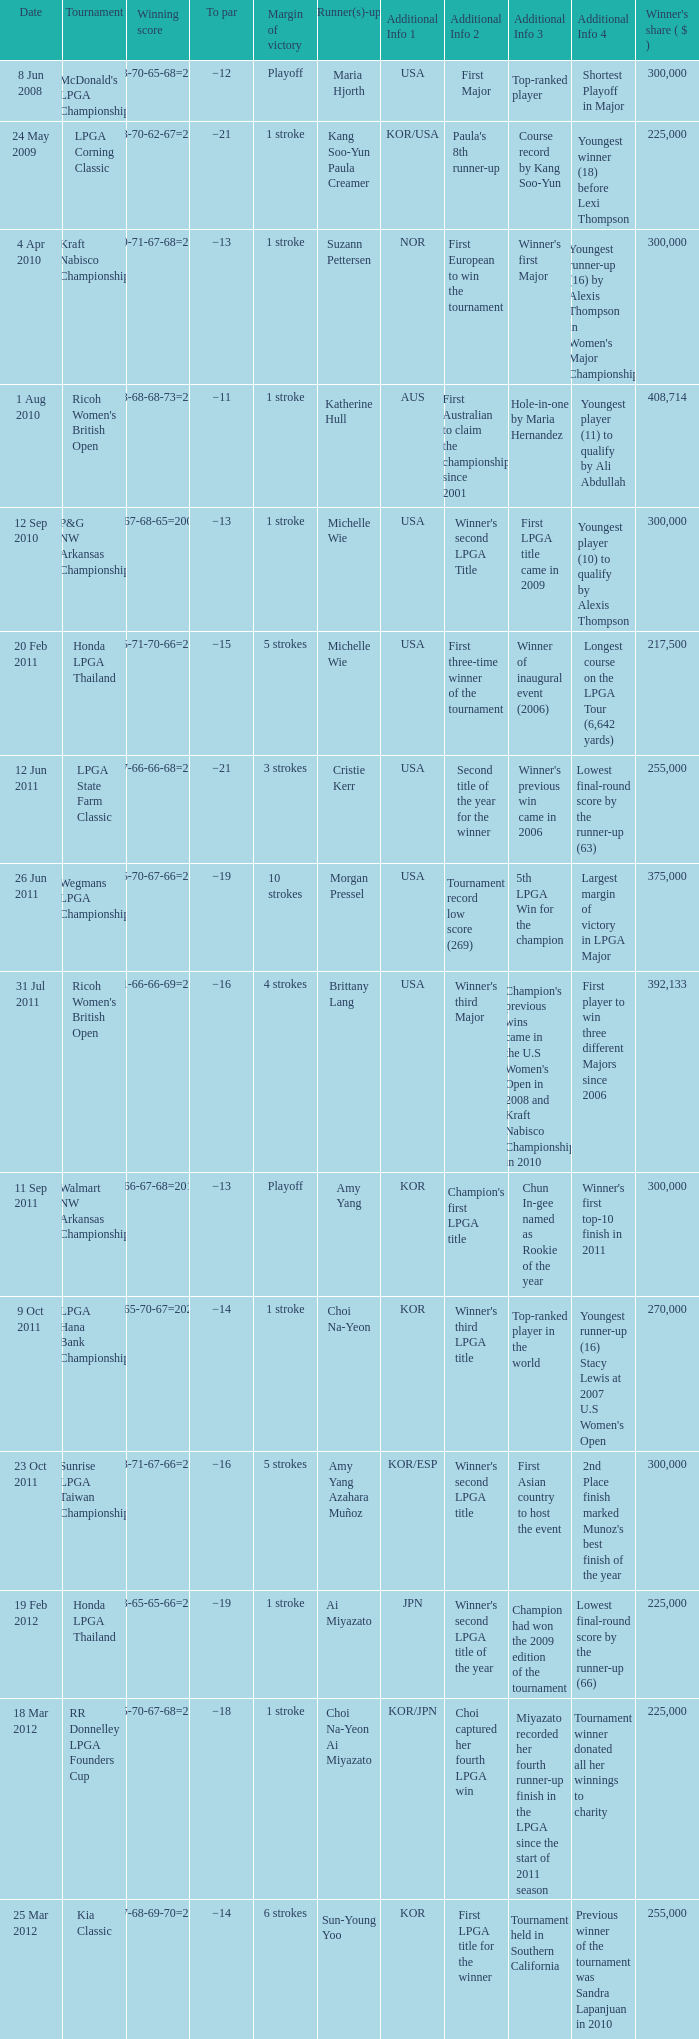Who was the runner-up in the RR Donnelley LPGA Founders Cup? Choi Na-Yeon Ai Miyazato. 